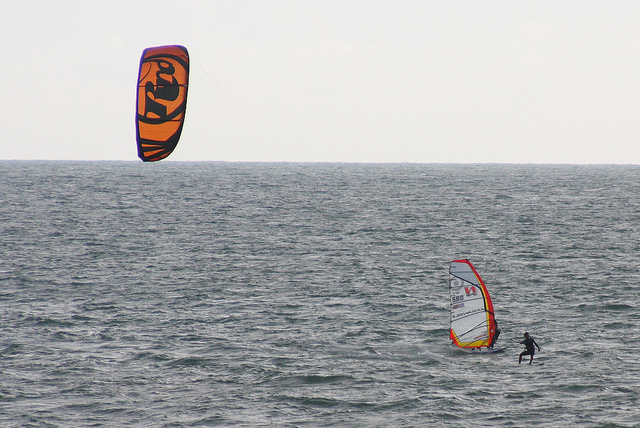Imagine a story involving these two individuals. What could be their background or relationship? In a small coastal town, two childhood friends, Alex and Jamie, grew up with a shared love for the ocean. Alex, the windsurfer, pursued a career as a marine biologist, studying the secrets of the sea, while Jamie, the parasailer, became a professional kitesurfing instructor. Despite their busy lives, they reunite every summer at their favorite spot, reliving their youthful adventures and strengthening their bond through their shared passion for water sports. What kind of training and preparation might be involved for these sports? Training for parasailing and windsurfing involves building physical strength, particularly in the core, arms, and legs. For parasailing, individuals must learn to balance and control the sail, understand wind patterns, and perfect safe take-off and landing techniques. Windsurfing requires mastering the art of balancing on the board, steering with the sail, and navigating through different wave and wind conditions. Safety preparations are crucial for both sports, including checking equipment, wearing appropriate safety gear, and understanding emergency procedures. If the orange parasail could talk, what story would it tell? The orange parasail, with its many tales woven into its vibrant fabric, would recount the exhilarating moments of flight. It would narrate the times it soared high above crystalline waters, dancing with the wind, catching glimmers of sunlight, and offering unparalleled views of the shoreline. It would share stories of adventure, the thrill of catching the perfect gust of wind, and the joy of providing a bird's-eye view to its riders. Its stories would be filled with the sounds of laughter, the splash of waves, and the sheer joy of freedom that comes from flying over the boundless ocean. 